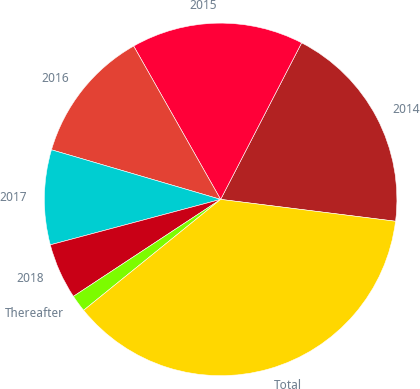Convert chart. <chart><loc_0><loc_0><loc_500><loc_500><pie_chart><fcel>2014<fcel>2015<fcel>2016<fcel>2017<fcel>2018<fcel>Thereafter<fcel>Total<nl><fcel>19.38%<fcel>15.81%<fcel>12.25%<fcel>8.69%<fcel>5.12%<fcel>1.56%<fcel>37.19%<nl></chart> 